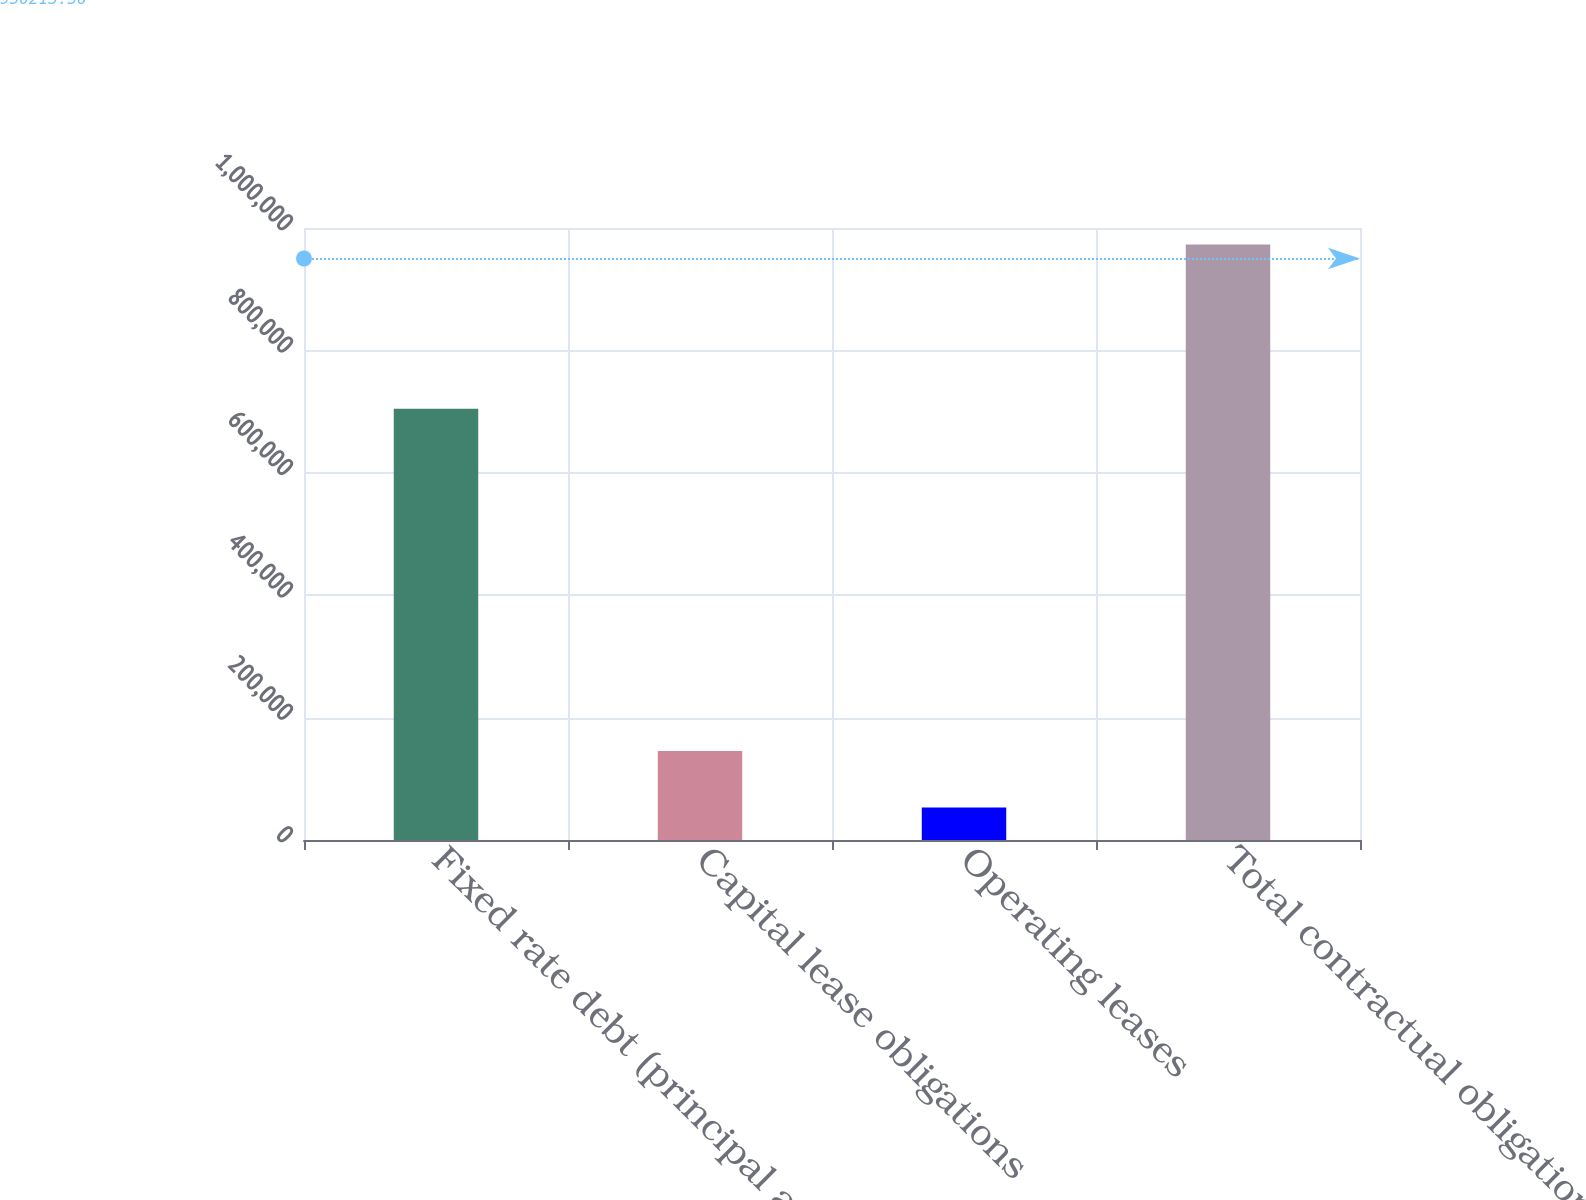Convert chart to OTSL. <chart><loc_0><loc_0><loc_500><loc_500><bar_chart><fcel>Fixed rate debt (principal and<fcel>Capital lease obligations<fcel>Operating leases<fcel>Total contractual obligations<nl><fcel>704790<fcel>145242<fcel>53281<fcel>972891<nl></chart> 